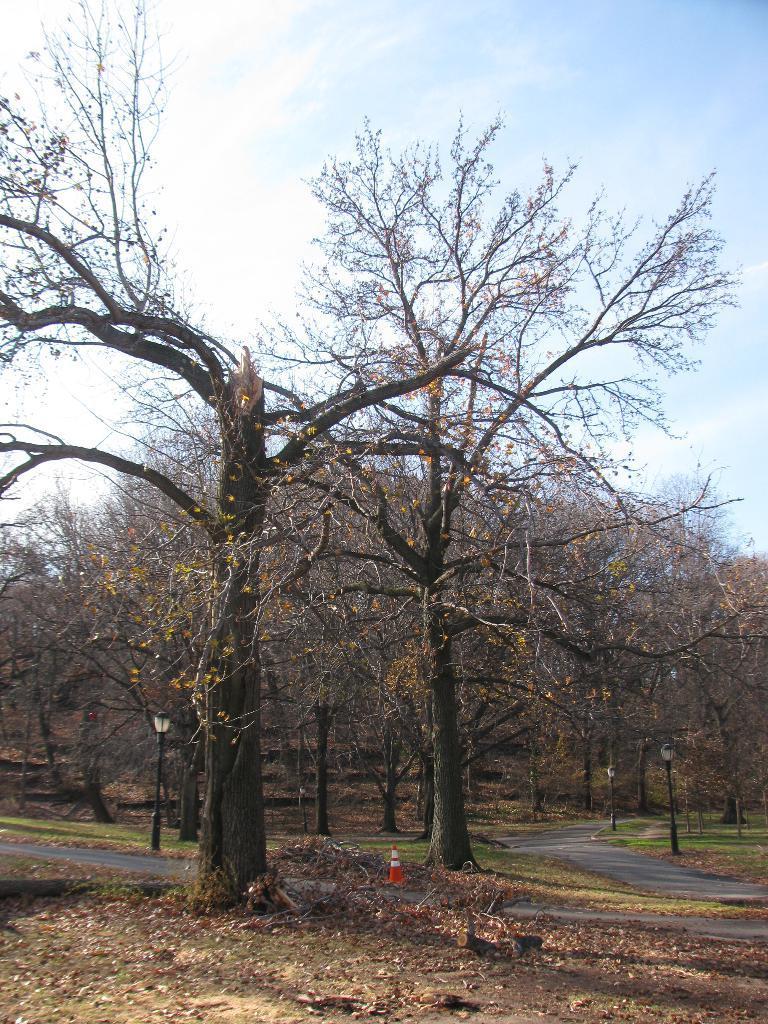Please provide a concise description of this image. In this picture we can see leaves, grass, road, traffic cone, lights on poles and trees. In the background of the image we can see sky with clouds. 